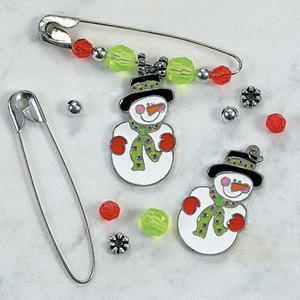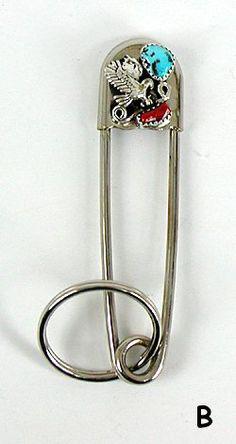The first image is the image on the left, the second image is the image on the right. For the images shown, is this caption "There is one pin in the right image." true? Answer yes or no. Yes. The first image is the image on the left, the second image is the image on the right. Examine the images to the left and right. Is the description "There are no less than three plain safety pins without any beads" accurate? Answer yes or no. No. 